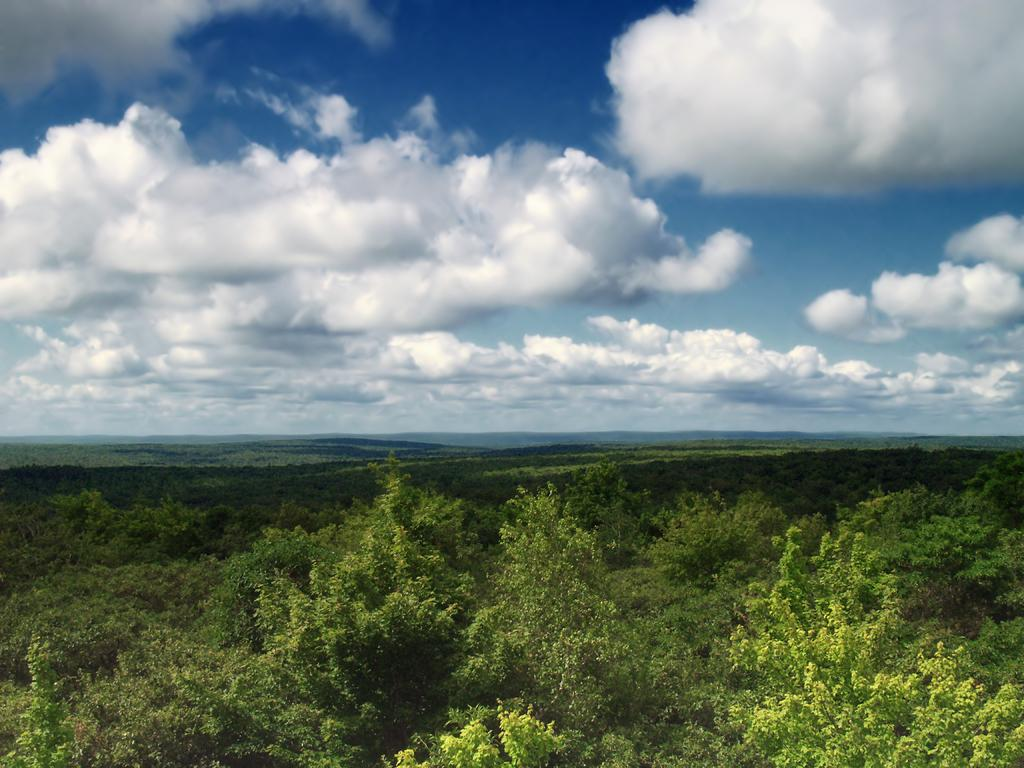What type of vegetation is present in the image? There are trees in the image. Can you describe the trees in more detail? The trees have branches and leaves. What is visible in the sky in the image? There are clouds visible in the sky. What type of development is taking place in the image? There is no indication of any development taking place in the image; it primarily features trees and clouds. Can you tell me which parent is present in the image? There are no people, let alone parents, present in the image. 